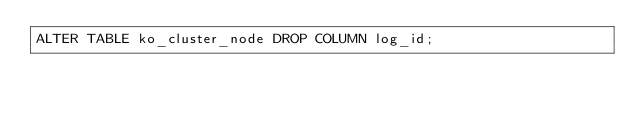<code> <loc_0><loc_0><loc_500><loc_500><_SQL_>ALTER TABLE ko_cluster_node DROP COLUMN log_id;
</code> 